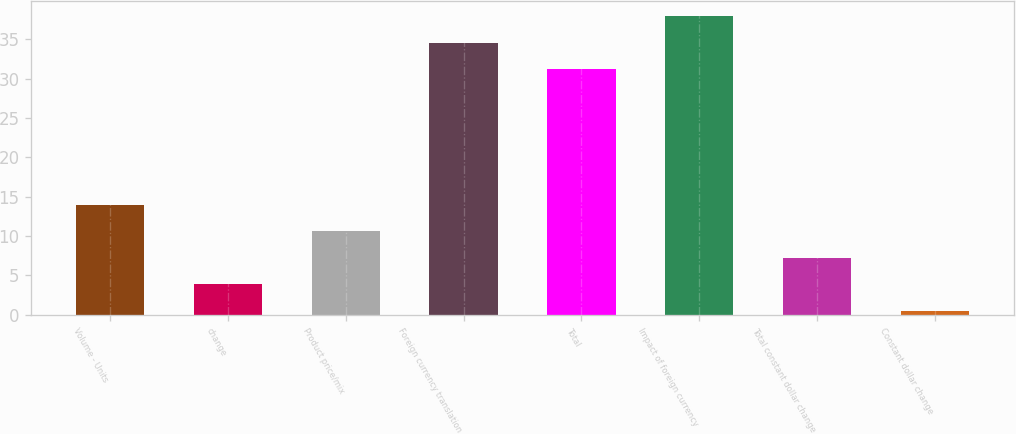Convert chart. <chart><loc_0><loc_0><loc_500><loc_500><bar_chart><fcel>Volume - Units<fcel>change<fcel>Product price/mix<fcel>Foreign currency translation<fcel>Total<fcel>Impact of foreign currency<fcel>Total constant dollar change<fcel>Constant dollar change<nl><fcel>13.94<fcel>3.86<fcel>10.58<fcel>34.56<fcel>31.2<fcel>37.92<fcel>7.22<fcel>0.5<nl></chart> 